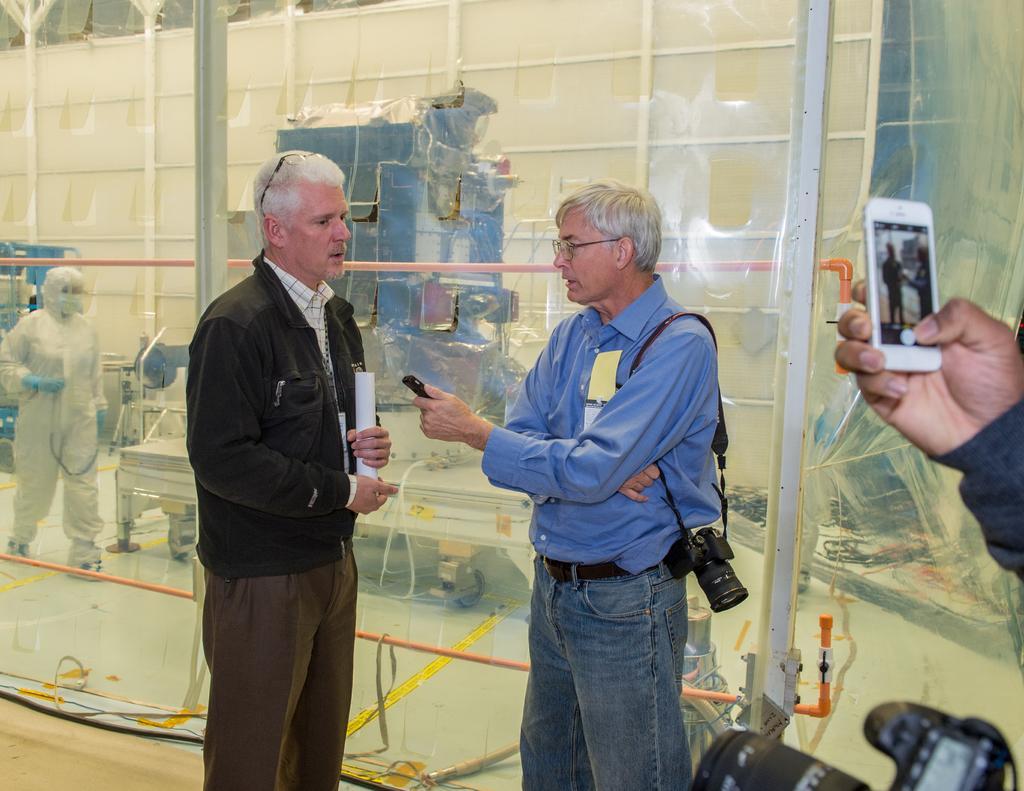How would you summarize this image in a sentence or two? In this picture there are two men in the center of the image, it seems to be they are talking and there is a man on the right side of the image, who is taking a photo from the phone and there is a camera at the bottom side of the image, there are machines and a man which are visible from the grass windows. 